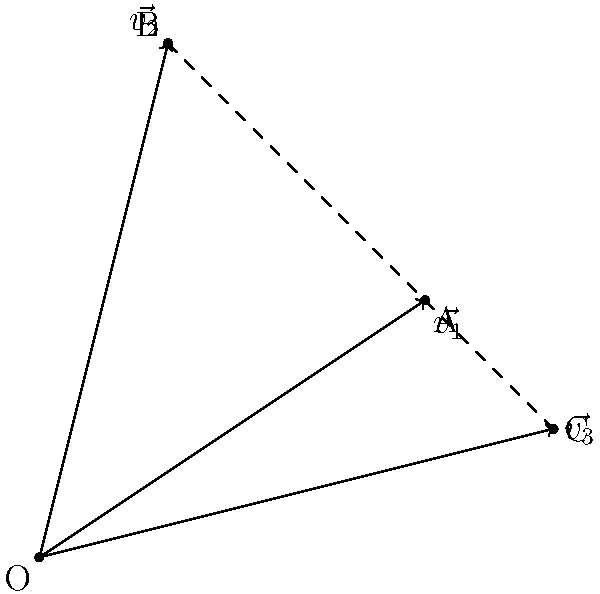During a training session, you observe three consecutive passes from different players. The first pass is represented by vector $\vec{v_1} = (3,2)$, the second by $\vec{v_2} = (1,4)$, and the third by $\vec{v_3} = (4,1)$. What is the magnitude of the resultant vector when all three passes are combined? To find the magnitude of the resultant vector, we need to follow these steps:

1) First, we need to add all three vectors:
   $\vec{v_{resultant}} = \vec{v_1} + \vec{v_2} + \vec{v_3}$

2) Adding the x-components:
   $x_{resultant} = 3 + 1 + 4 = 8$

3) Adding the y-components:
   $y_{resultant} = 2 + 4 + 1 = 7$

4) So, the resultant vector is $\vec{v_{resultant}} = (8,7)$

5) To find the magnitude, we use the Pythagorean theorem:
   $|\vec{v_{resultant}}| = \sqrt{x^2 + y^2}$

6) Substituting our values:
   $|\vec{v_{resultant}}| = \sqrt{8^2 + 7^2}$

7) Simplifying:
   $|\vec{v_{resultant}}| = \sqrt{64 + 49} = \sqrt{113}$

Therefore, the magnitude of the resultant vector is $\sqrt{113}$ units.
Answer: $\sqrt{113}$ units 